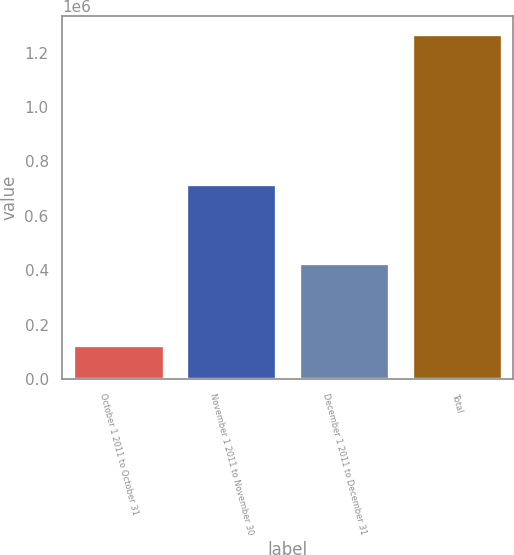Convert chart to OTSL. <chart><loc_0><loc_0><loc_500><loc_500><bar_chart><fcel>October 1 2011 to October 31<fcel>November 1 2011 to November 30<fcel>December 1 2011 to December 31<fcel>Total<nl><fcel>125621<fcel>717639<fcel>427355<fcel>1.27062e+06<nl></chart> 